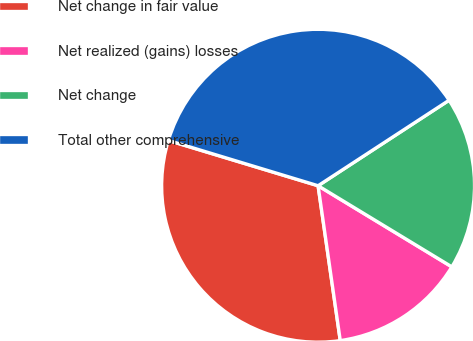Convert chart. <chart><loc_0><loc_0><loc_500><loc_500><pie_chart><fcel>Net change in fair value<fcel>Net realized (gains) losses<fcel>Net change<fcel>Total other comprehensive<nl><fcel>31.94%<fcel>14.06%<fcel>17.88%<fcel>36.12%<nl></chart> 